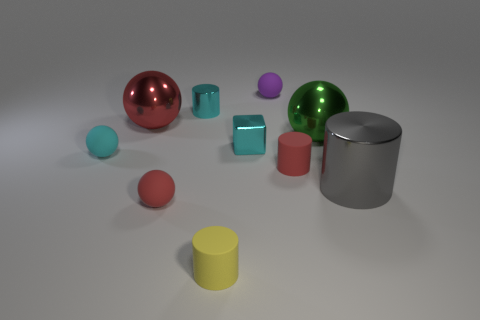What is the material of the small red ball?
Provide a short and direct response. Rubber. There is a metal object that is right of the tiny purple rubber sphere and in front of the green metal object; what size is it?
Your answer should be compact. Large. There is a cylinder that is the same color as the shiny cube; what is it made of?
Provide a succinct answer. Metal. How many cyan rubber balls are there?
Offer a very short reply. 1. Are there fewer large green rubber things than tiny red matte objects?
Make the answer very short. Yes. What material is the purple thing that is the same size as the yellow cylinder?
Give a very brief answer. Rubber. How many things are either big yellow metal cylinders or small rubber spheres?
Keep it short and to the point. 3. What number of small balls are on the left side of the small purple rubber sphere and behind the large gray metal object?
Offer a very short reply. 1. Is the number of matte cylinders that are on the left side of the tiny metal cube less than the number of gray metallic balls?
Offer a terse response. No. What is the shape of the yellow rubber object that is the same size as the cyan matte ball?
Provide a succinct answer. Cylinder. 